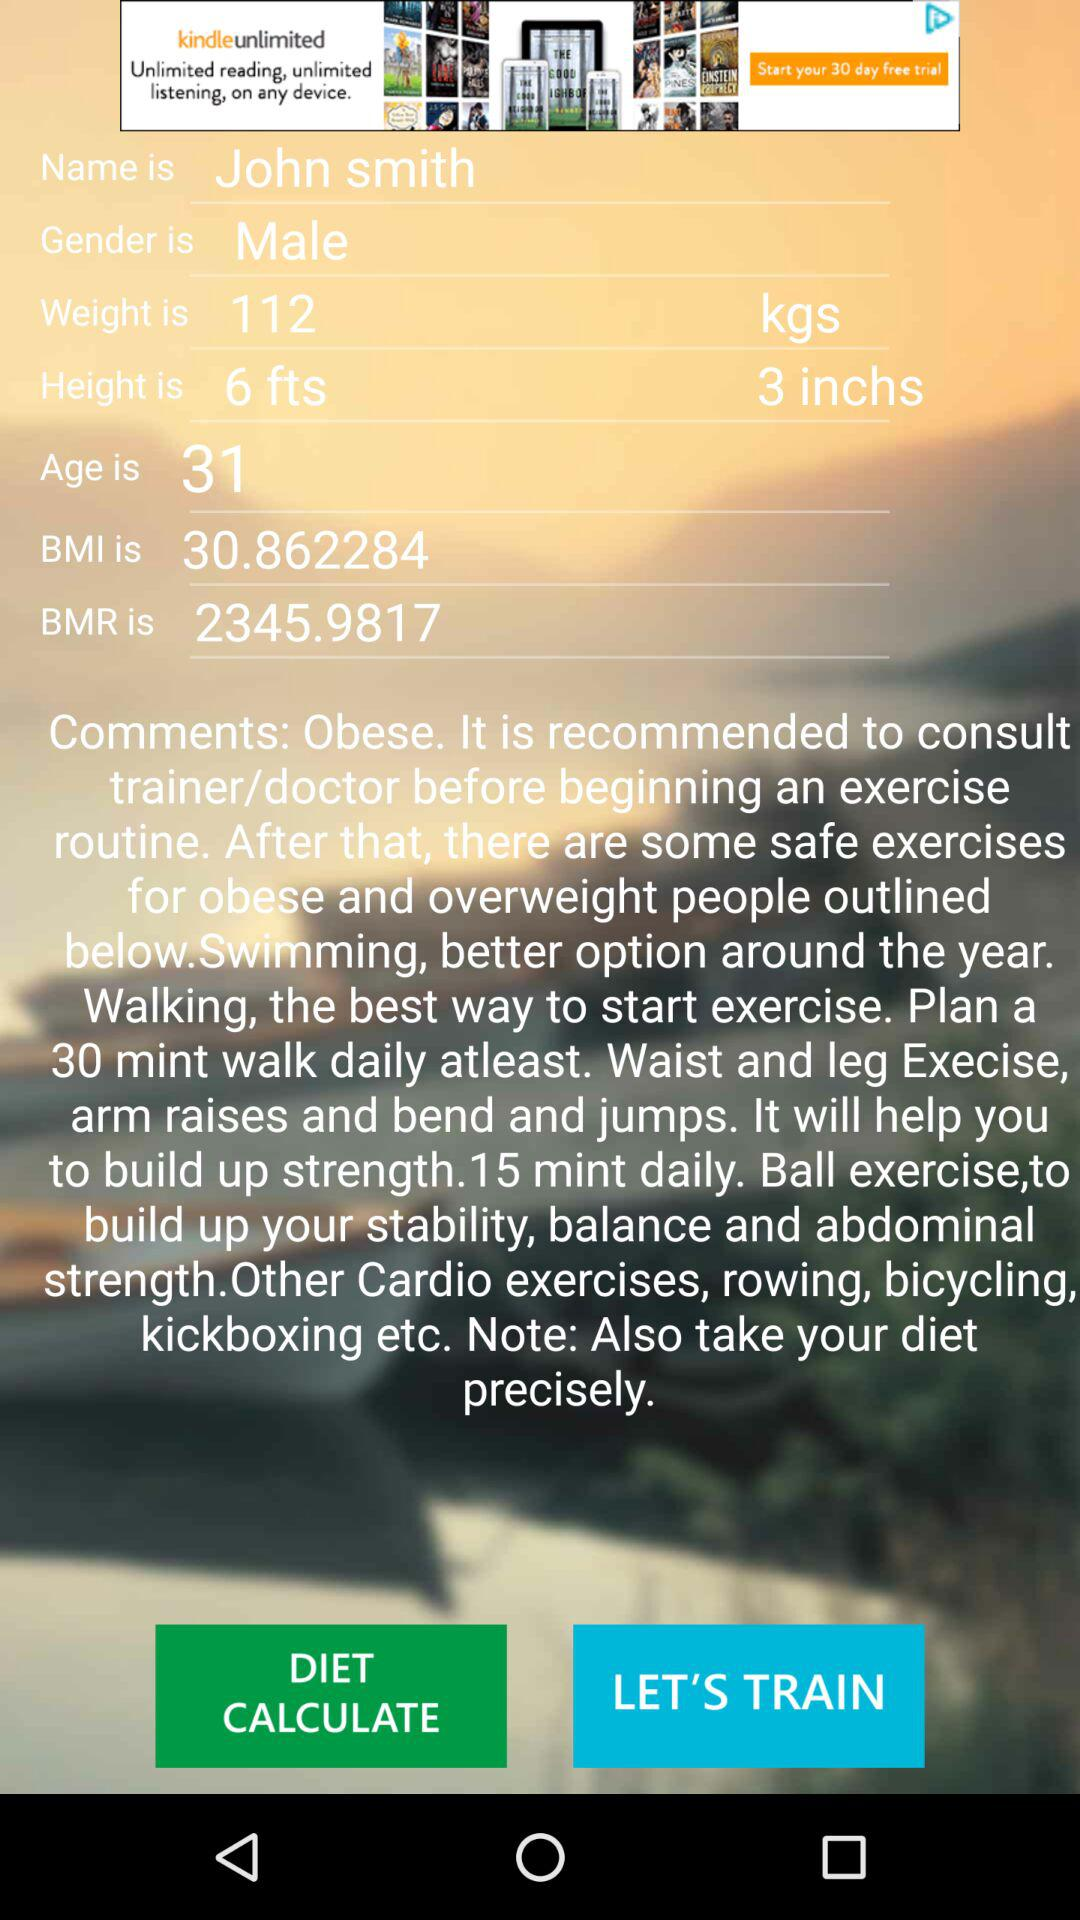What is the height? The height is 6 feet 3 inches. 